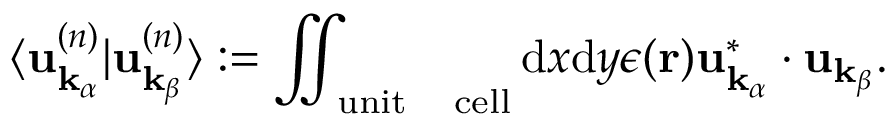<formula> <loc_0><loc_0><loc_500><loc_500>\langle u _ { k _ { \alpha } } ^ { ( n ) } | u _ { k _ { \beta } } ^ { ( n ) } \rangle \colon = \iint _ { u n i t \quad c e l l } d x d y \epsilon ( r ) u _ { k _ { \alpha } } ^ { * } \cdot u _ { k _ { \beta } } .</formula> 